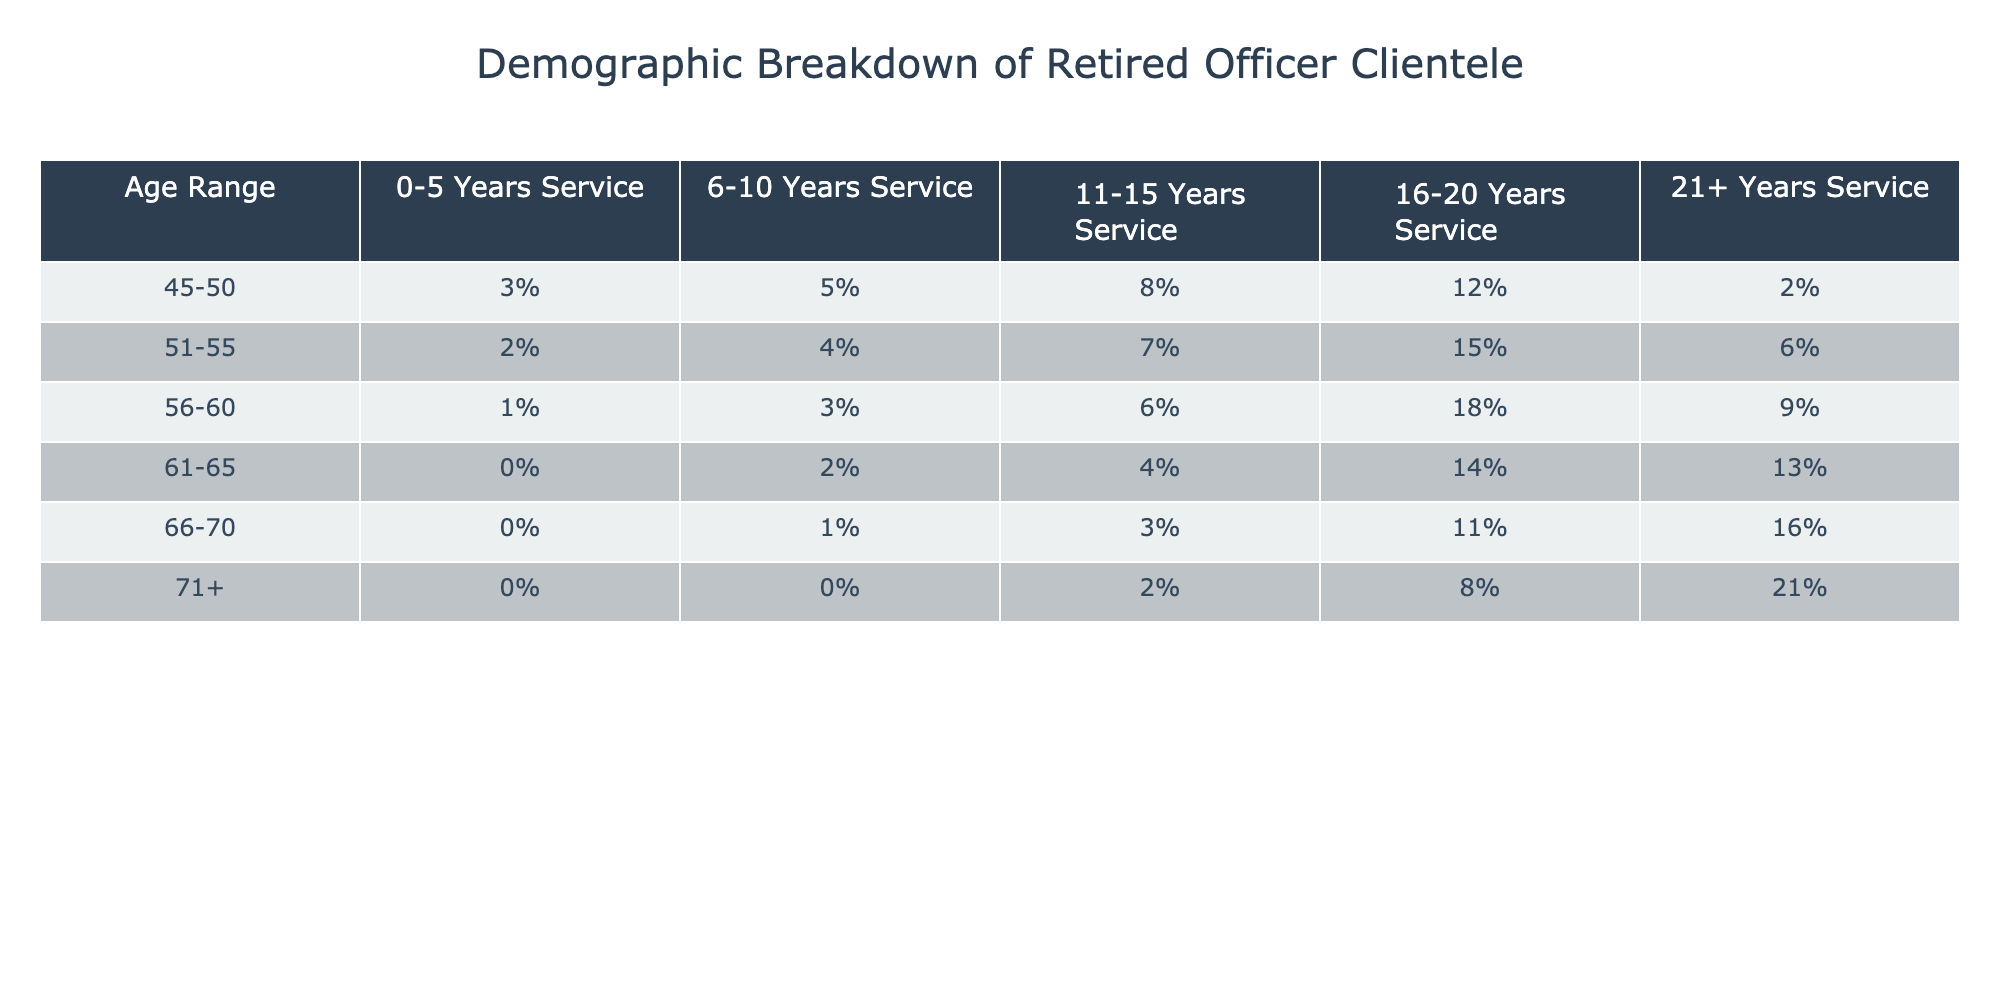What percentage of retired officers aged 61-65 served for 21+ years? Referring to the table, the percentage of retired officers aged 61-65 with 21+ years of service is directly listed under that age range and service category, which is 13%.
Answer: 13% Which age range has the highest percentage of retired officers with 16-20 years of service? Looking across the row for each age range under the 16-20 years service column, we find that the 56-60 age range has the highest percentage at 18%.
Answer: 56-60 How many age groups have 0% representation for 0-5 years of service? By examining the data in the first column (0-5 Years Service), we find that only the age group 61-65, 66-70, and 71+ have 0%, totaling three groups.
Answer: 3 What is the average percentage of retired officers with 6-10 years of service across all age ranges? To calculate the average, sum the percentages for 6-10 years of service: 5% + 4% + 3% + 2% + 1% + 0% = 15%. Then divide by the number of age groups (6), giving an average of 15% / 6 = 2.5%.
Answer: 2.5% Is it true that more than 50% of retired officers aged 66-70 have 21+ years of service? Referring to the table, the percentage of retired officers aged 66-70 with 21+ years of service is 16%, which is not more than 50%. Therefore, the statement is false.
Answer: False Which service category has the lowest representation in the 71+ age group? By examining the 71+ age group's row, the category with the lowest percentage is 0-5 years of service, which is 0%.
Answer: 0% If we consider the 45-50 age group, what is the combined percentage of those with 11-15 and 16-20 years of service? The percentages for the 45-50 age group are 8% for 11-15 years and 12% for 16-20 years. Adding these gives 8% + 12% = 20%.
Answer: 20% What is the ratio of retired officers aged 56-60 with 21+ years of service to those aged 61-65 with the same service duration? For 56-60, the percentage with 21+ years of service is 9%, and for 61-65, it's 13%. Therefore, the ratio is 9:13.
Answer: 9:13 How many more officers aged 51-55 served 16-20 years compared to those aged 61-65? From the table, 51-55 has 15% in the 16-20 category, and 61-65 has 14%. The difference is 15% - 14% = 1%.
Answer: 1% What is the total percentage of retired officers aged 66-70 across all years of service? Summing the percentages across the 66-70 row: 0 + 1 + 3 + 11 + 16 = 31%.
Answer: 31% 